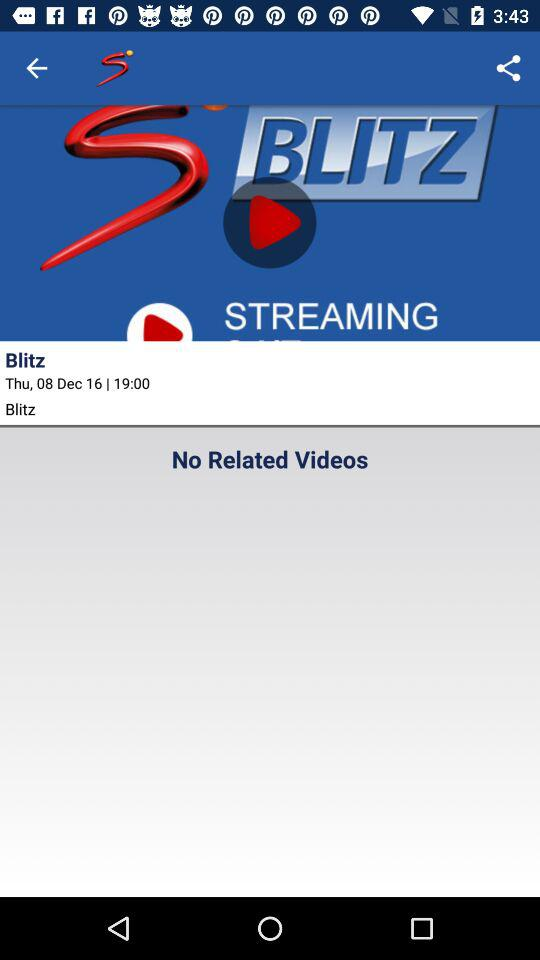Is there any related video? There is no related video. 